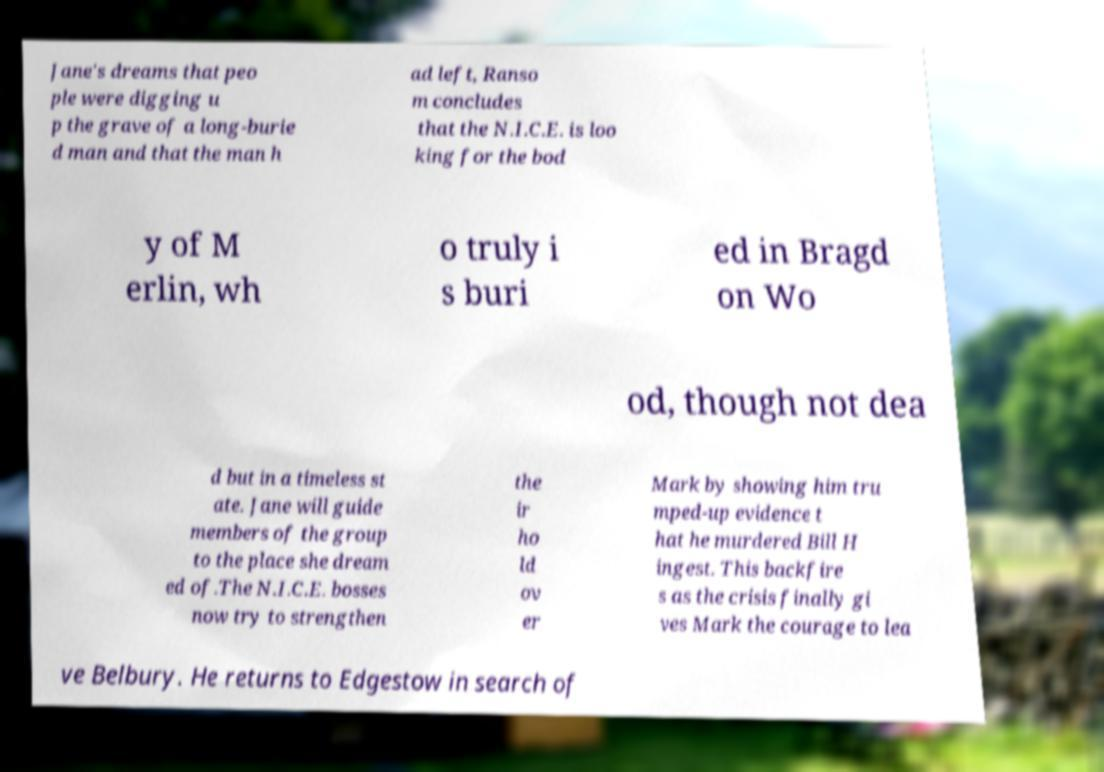Please read and relay the text visible in this image. What does it say? Jane's dreams that peo ple were digging u p the grave of a long-burie d man and that the man h ad left, Ranso m concludes that the N.I.C.E. is loo king for the bod y of M erlin, wh o truly i s buri ed in Bragd on Wo od, though not dea d but in a timeless st ate. Jane will guide members of the group to the place she dream ed of.The N.I.C.E. bosses now try to strengthen the ir ho ld ov er Mark by showing him tru mped-up evidence t hat he murdered Bill H ingest. This backfire s as the crisis finally gi ves Mark the courage to lea ve Belbury. He returns to Edgestow in search of 